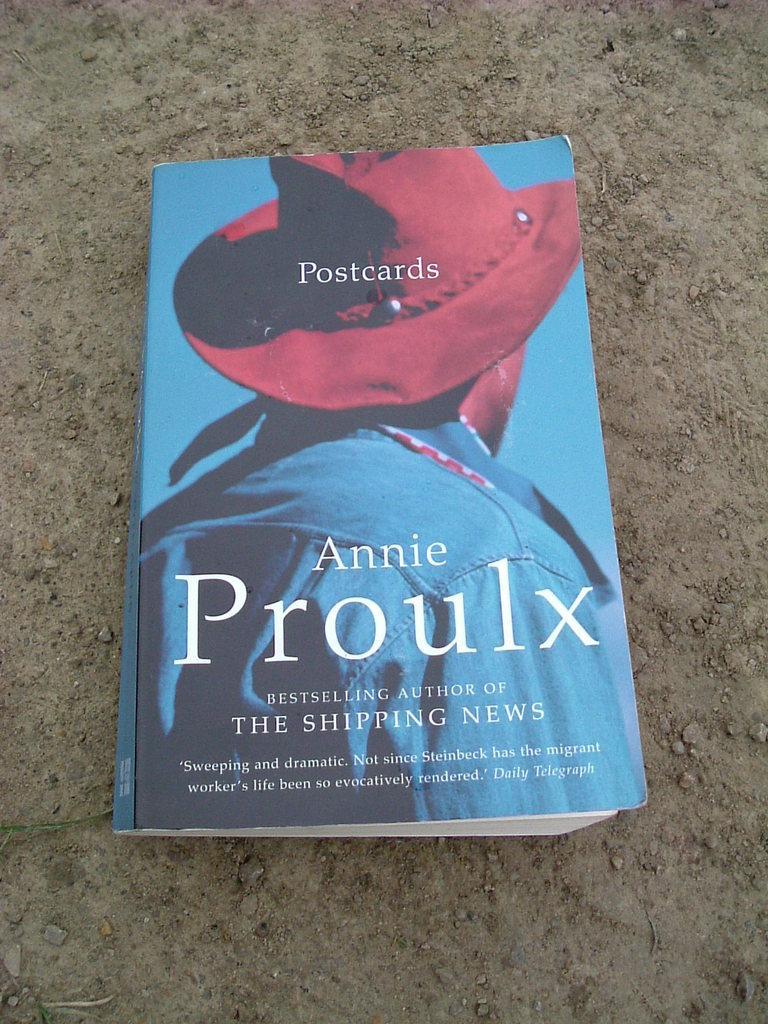Provide a one-sentence caption for the provided image. A book by Annie Proulx has a person in a red hat on it. 